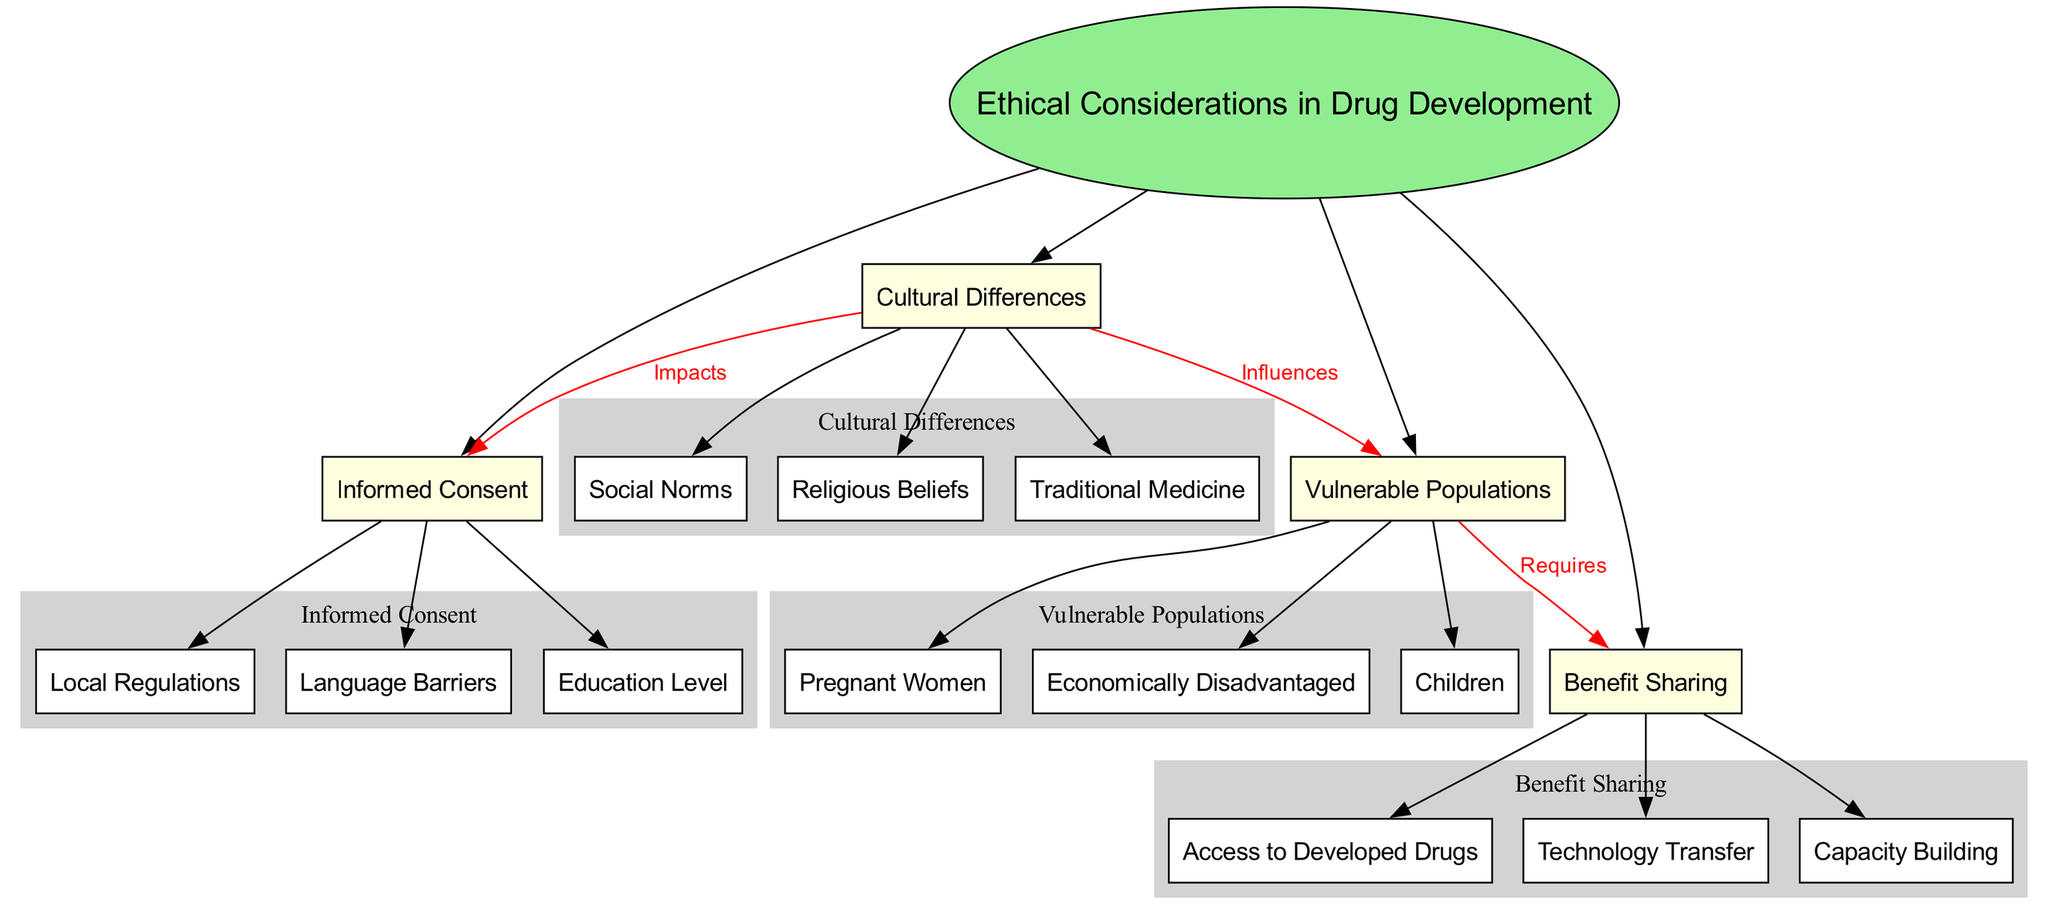What is the central concept of the diagram? The central concept is identified at the center of the diagram, labeled "Ethical Considerations in Drug Development."
Answer: Ethical Considerations in Drug Development How many main categories are present in the diagram? The main categories are connected directly to the central concept with edges. Counting them, there are four main categories listed.
Answer: 4 What are the subcategories under "Cultural Differences"? The subcategories are grouped under the "Cultural Differences" main category. They include "Religious Beliefs," "Traditional Medicine," and "Social Norms."
Answer: Religious Beliefs, Traditional Medicine, Social Norms Which main category influences "Vulnerable Populations"? The connection is shown with an edge labeled "Influences" from "Cultural Differences" to "Vulnerable Populations." This indicates the influence of cultural differences on vulnerable populations.
Answer: Cultural Differences What does "Vulnerable Populations" require in relation to "Benefit Sharing"? The diagram indicates this relationship with an edge labeled "Requires" from "Vulnerable Populations" to "Benefit Sharing," demonstrating that vulnerable populations have needs concerning benefit sharing.
Answer: Requires How do "Cultural Differences" impact "Informed Consent"? The diagram shows that "Cultural Differences" has an edge labeled "Impacts" leading to "Informed Consent," indicating that cultural aspects can affect the informed consent process.
Answer: Impacts How many subcategories are listed under "Informed Consent"? The investigative approach counts the subcategories displayed under this category: "Language Barriers," "Education Level," and "Local Regulations," totaling three subcategories.
Answer: 3 What forms of "Benefit Sharing" are included in the diagram? The subcategories under the "Benefit Sharing" main category are listed as "Access to Developed Drugs," "Technology Transfer," and "Capacity Building," which represent different aspects of benefit sharing.
Answer: Access to Developed Drugs, Technology Transfer, Capacity Building Which vulnerable population is listed that might have unique ethical considerations in drug development? "Children" is listed under the "Vulnerable Populations" category, highlighting that they have specific ethical considerations regarding drug development.
Answer: Children What is the primary type of relationship among the main categories in the diagram? The primary relationships shown include "Impacts," "Requires," and "Influences," highlighting how different aspects of ethical considerations interconnect among the main categories.
Answer: Impacts, Requires, Influences 